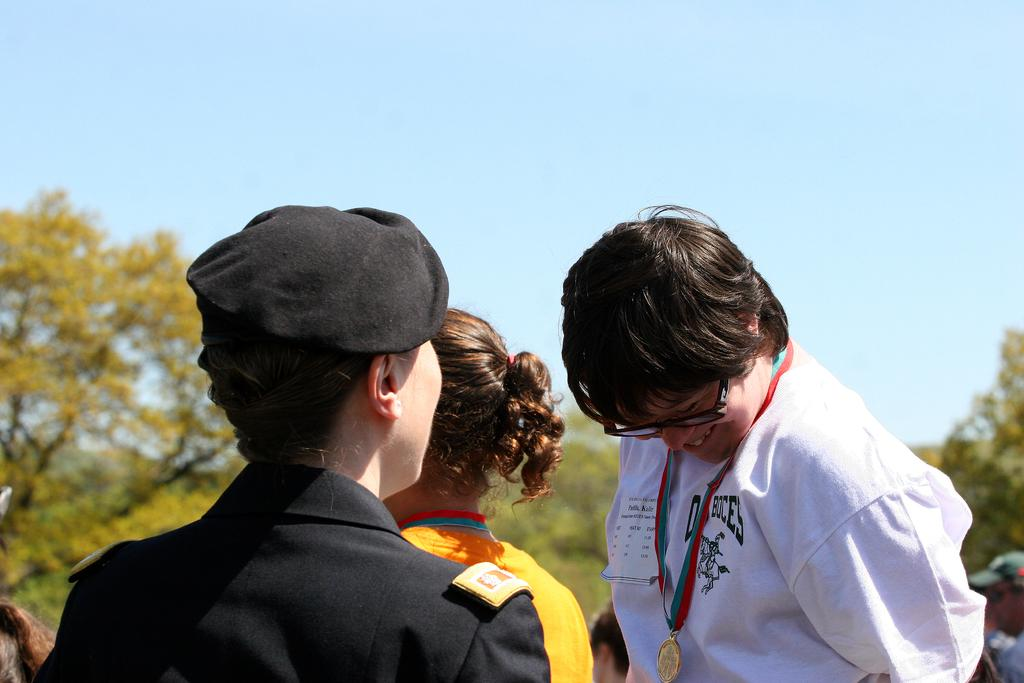What is the main subject of the image? The main subject of the image is people. Where are the people located in the image? The people are in the center of the image. What can be seen in the background of the image? There are trees in the background of the image. What type of sock is hanging from the tree in the image? There is no sock present in the image; it only features people and trees in the background. 